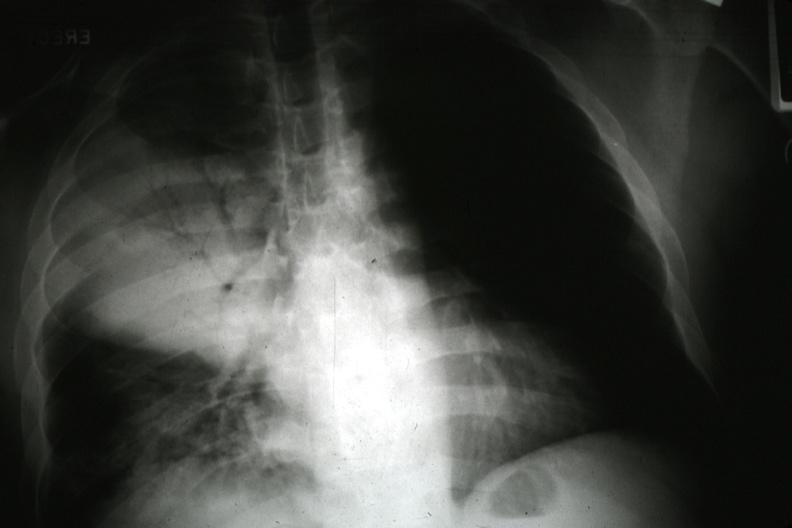what is present?
Answer the question using a single word or phrase. Lung 